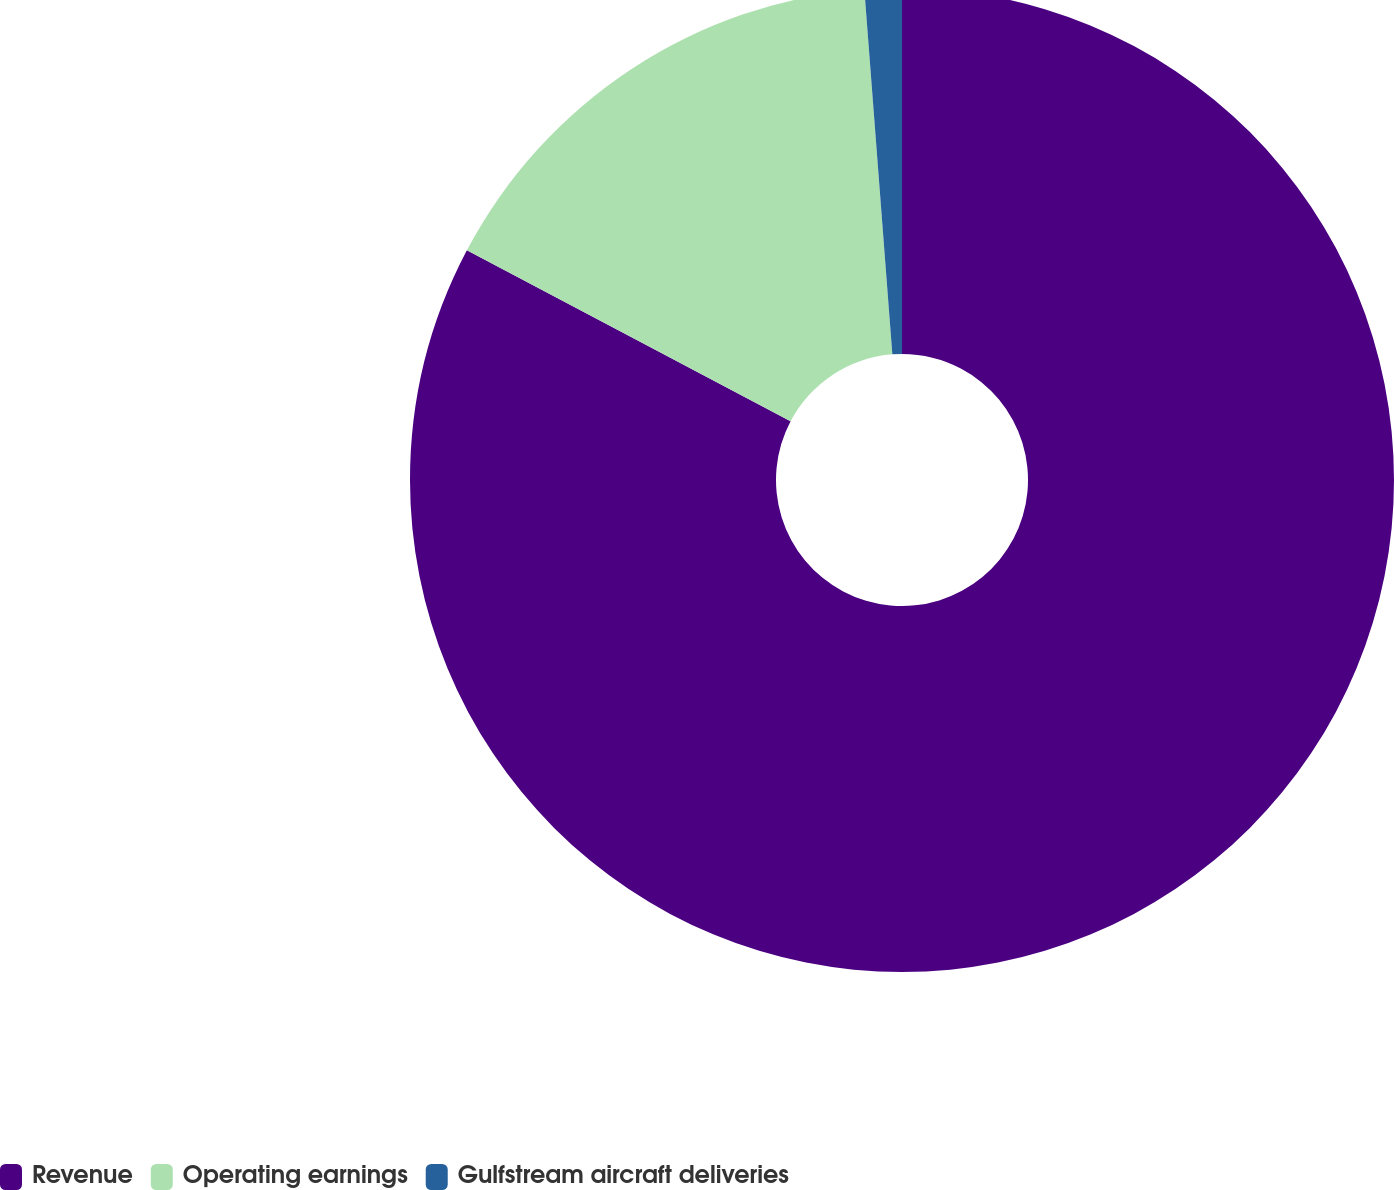Convert chart to OTSL. <chart><loc_0><loc_0><loc_500><loc_500><pie_chart><fcel>Revenue<fcel>Operating earnings<fcel>Gulfstream aircraft deliveries<nl><fcel>82.73%<fcel>16.05%<fcel>1.22%<nl></chart> 